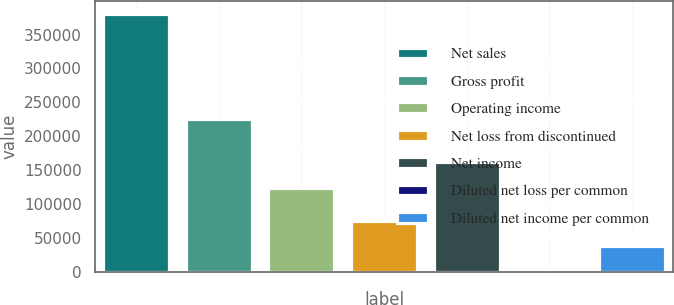<chart> <loc_0><loc_0><loc_500><loc_500><bar_chart><fcel>Net sales<fcel>Gross profit<fcel>Operating income<fcel>Net loss from discontinued<fcel>Net income<fcel>Diluted net loss per common<fcel>Diluted net income per common<nl><fcel>379985<fcel>225591<fcel>124361<fcel>75997<fcel>162360<fcel>0.03<fcel>37998.5<nl></chart> 